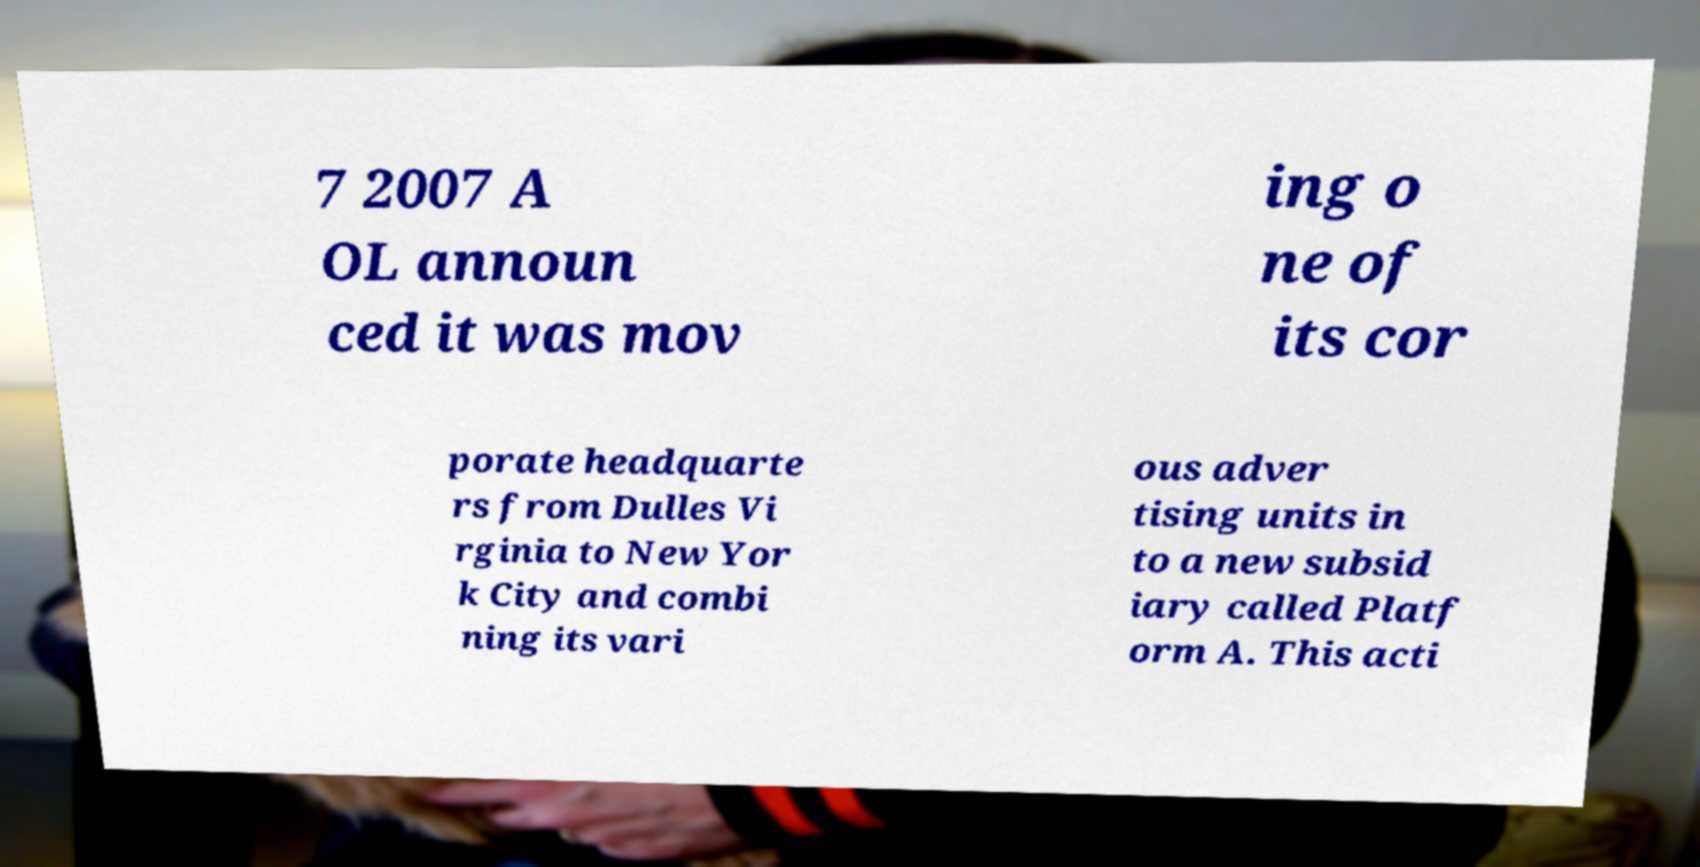There's text embedded in this image that I need extracted. Can you transcribe it verbatim? 7 2007 A OL announ ced it was mov ing o ne of its cor porate headquarte rs from Dulles Vi rginia to New Yor k City and combi ning its vari ous adver tising units in to a new subsid iary called Platf orm A. This acti 